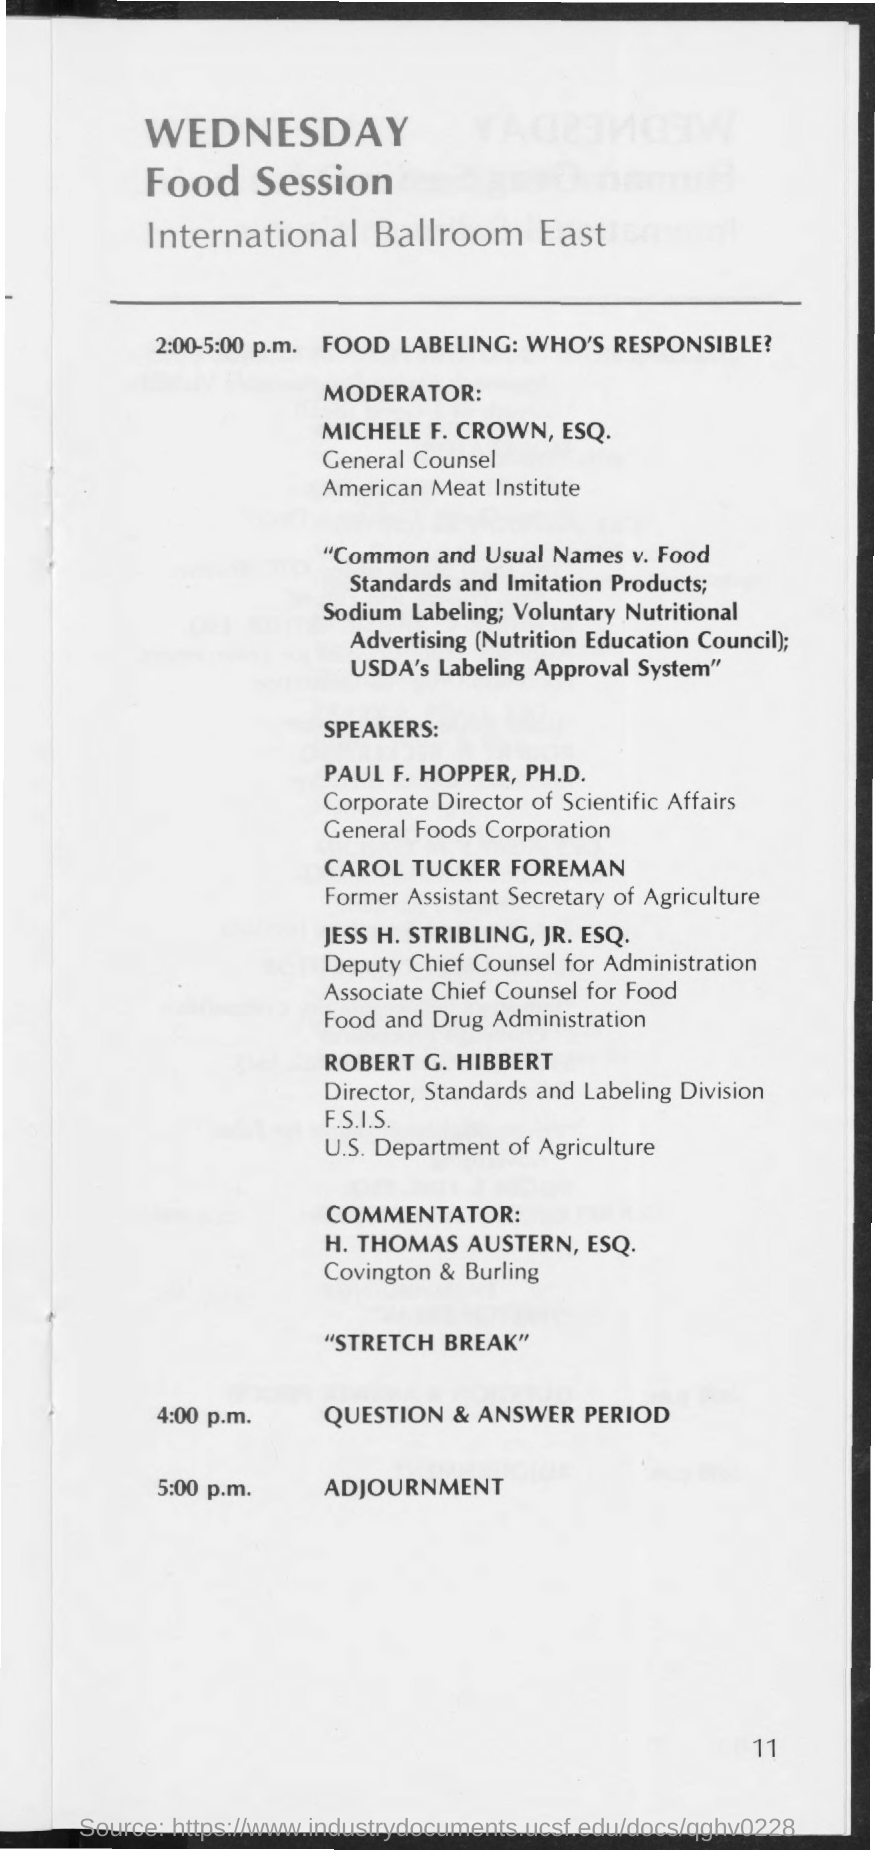Who is the moderator?
Provide a short and direct response. Michele F. Crown, ESQ. When is the question & answer period?
Ensure brevity in your answer.  4:00 p.m. 